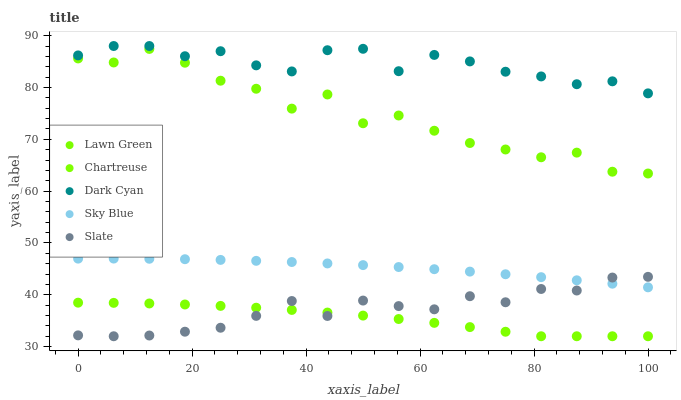Does Chartreuse have the minimum area under the curve?
Answer yes or no. Yes. Does Dark Cyan have the maximum area under the curve?
Answer yes or no. Yes. Does Lawn Green have the minimum area under the curve?
Answer yes or no. No. Does Lawn Green have the maximum area under the curve?
Answer yes or no. No. Is Sky Blue the smoothest?
Answer yes or no. Yes. Is Lawn Green the roughest?
Answer yes or no. Yes. Is Chartreuse the smoothest?
Answer yes or no. No. Is Chartreuse the roughest?
Answer yes or no. No. Does Chartreuse have the lowest value?
Answer yes or no. Yes. Does Lawn Green have the lowest value?
Answer yes or no. No. Does Dark Cyan have the highest value?
Answer yes or no. Yes. Does Lawn Green have the highest value?
Answer yes or no. No. Is Sky Blue less than Dark Cyan?
Answer yes or no. Yes. Is Dark Cyan greater than Lawn Green?
Answer yes or no. Yes. Does Slate intersect Chartreuse?
Answer yes or no. Yes. Is Slate less than Chartreuse?
Answer yes or no. No. Is Slate greater than Chartreuse?
Answer yes or no. No. Does Sky Blue intersect Dark Cyan?
Answer yes or no. No. 